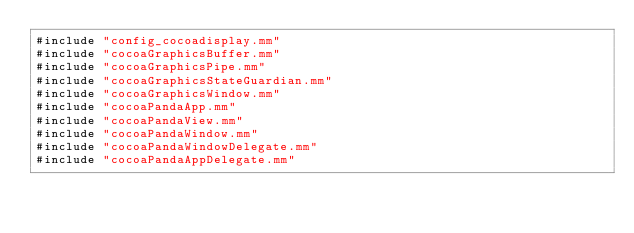<code> <loc_0><loc_0><loc_500><loc_500><_ObjectiveC_>#include "config_cocoadisplay.mm"
#include "cocoaGraphicsBuffer.mm"
#include "cocoaGraphicsPipe.mm"
#include "cocoaGraphicsStateGuardian.mm"
#include "cocoaGraphicsWindow.mm"
#include "cocoaPandaApp.mm"
#include "cocoaPandaView.mm"
#include "cocoaPandaWindow.mm"
#include "cocoaPandaWindowDelegate.mm"
#include "cocoaPandaAppDelegate.mm"
</code> 